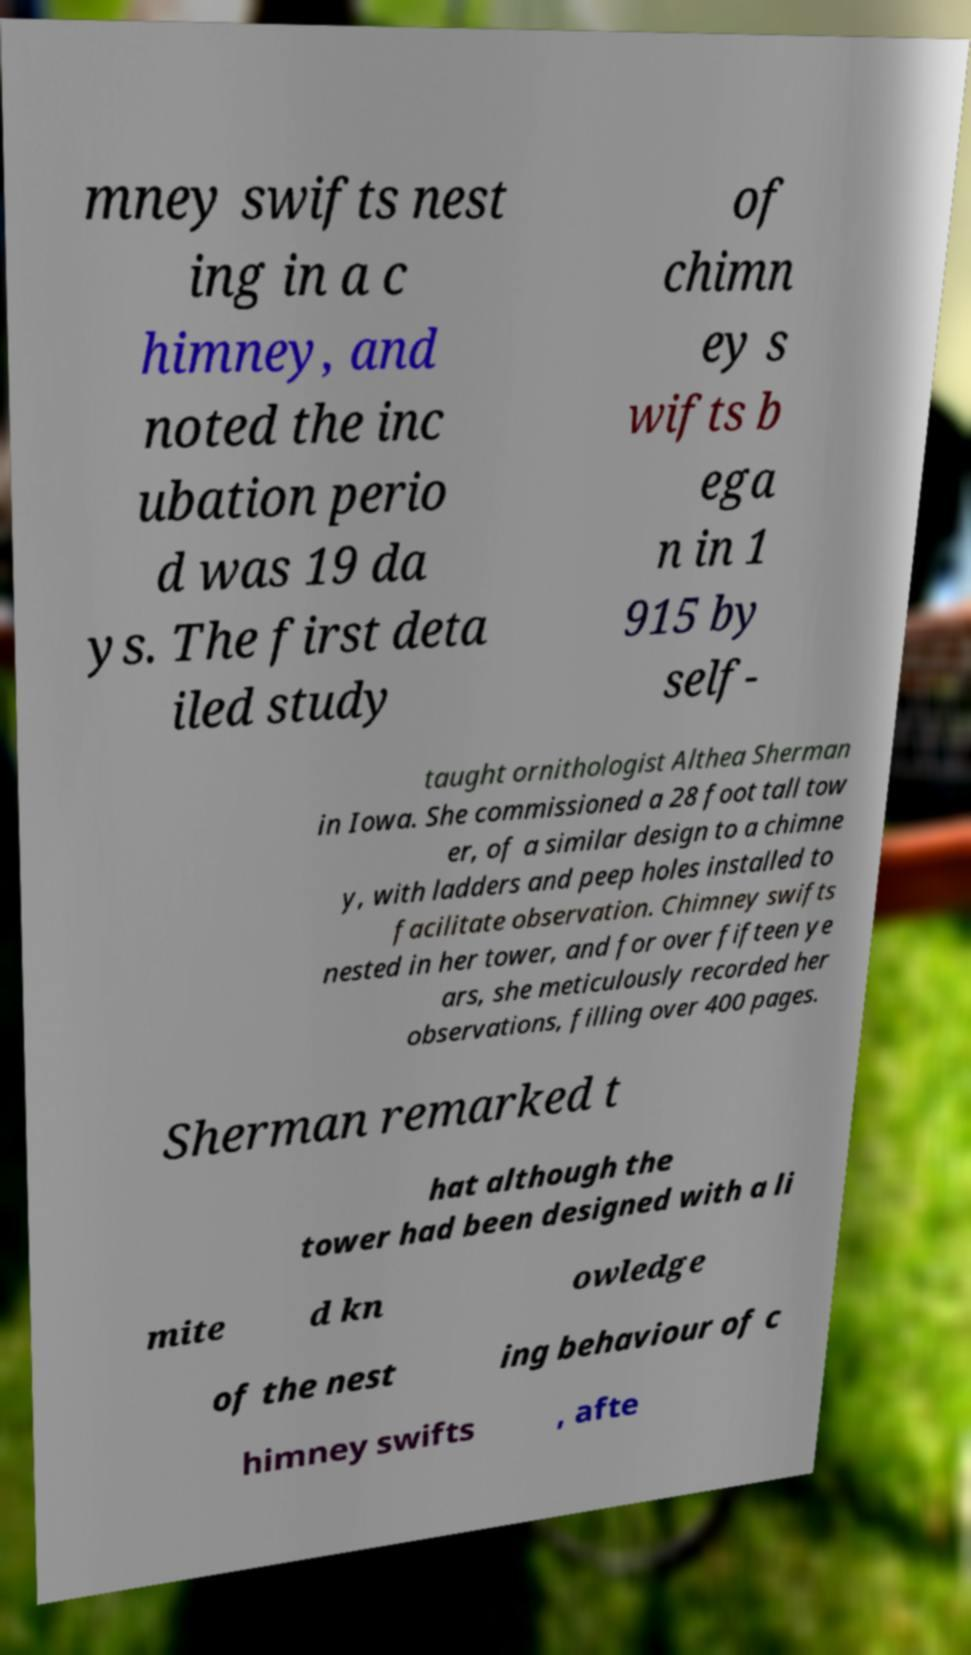Please identify and transcribe the text found in this image. mney swifts nest ing in a c himney, and noted the inc ubation perio d was 19 da ys. The first deta iled study of chimn ey s wifts b ega n in 1 915 by self- taught ornithologist Althea Sherman in Iowa. She commissioned a 28 foot tall tow er, of a similar design to a chimne y, with ladders and peep holes installed to facilitate observation. Chimney swifts nested in her tower, and for over fifteen ye ars, she meticulously recorded her observations, filling over 400 pages. Sherman remarked t hat although the tower had been designed with a li mite d kn owledge of the nest ing behaviour of c himney swifts , afte 